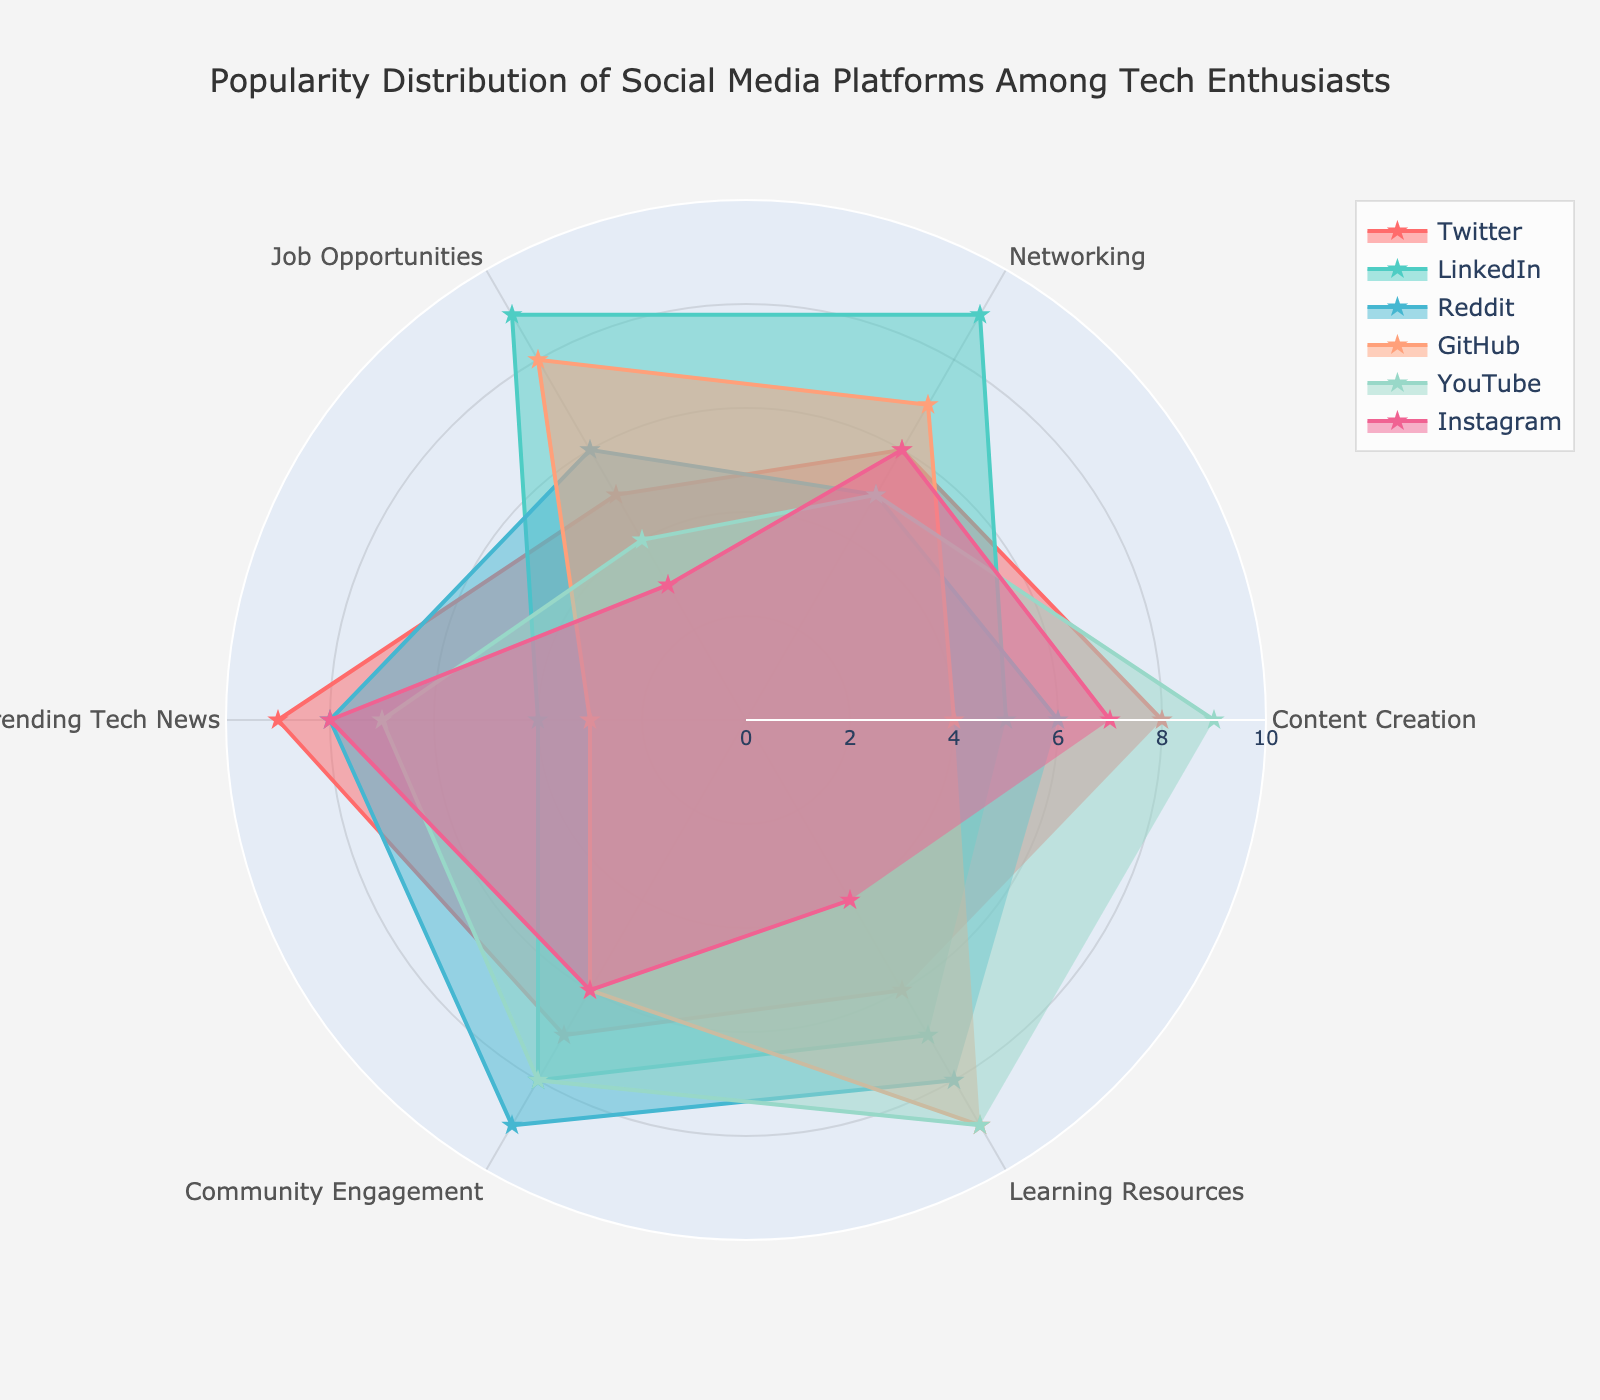what is the title of the figure? The title of the figure is typically placed at the top center of the chart. By looking at this location, we can see the textual information provided as the title.
Answer: Popularity Distribution of Social Media Platforms Among Tech Enthusiasts how many categories are used to evaluate the social media platforms? The radar chart uses axes to represent different categories or attributes. By counting the number of axes, we can determine the number of categories.
Answer: 6 which platform is rated the highest for content creation? Each axis represents a category, and the value is plotted as a point on the axis. By observing the values for the "Content Creation" category on the radar chart, we can identify the platform with the highest value.
Answer: YouTube what's the average rating for Twitter across all categories? To compute the average rating, sum the values across all categories for Twitter and divide by the number of categories. The values for Twitter are 8, 6, 5, 9, 7, and 6. Sum = 41. Average = 41/6.
Answer: 6.83 which platform shows the most balanced performance across all categories? A balanced radar chart will have a shape close to a regular polygon around the center. By visually inspecting the chart, we can identify which platform’s radar plot appears more even and balanced around the center.
Answer: Reddit which platform scores the lowest for job opportunities, and what is the score? Observe the "Job Opportunities" axis for each platform and identify the smallest value. Look at the platform associated with that value.
Answer: Instagram, 3 how do LinkedIn and GitHub compare in terms of job opportunities? Compare the values for the "Job Opportunities" category for LinkedIn and GitHub. LinkedIn has a value of 9, and GitHub has a value of 8.
Answer: LinkedIn scores higher if you sum the scores for community engagement for all platforms, what do you get? Add the values for the "Community Engagement" category for all the platforms. The values are 7, 8, 9, 6, 8, and 6. Sum = 7 + 8 + 9 + 6 + 8 + 6
Answer: 44 which platform is the best for learning resources, according to the chart? Look at the "Learning Resources" category and identify the platform with the highest value on the radar chart. YouTube and GitHub both have the highest value of 9.
Answer: YouTube, GitHub what is the difference in the networking scores between Reddit and LinkedIn? Locate the values for the "Networking" category for Reddit and LinkedIn. Reddit has a value of 5, and LinkedIn has a value of 9. The difference is calculated as 9 - 5.
Answer: 4 